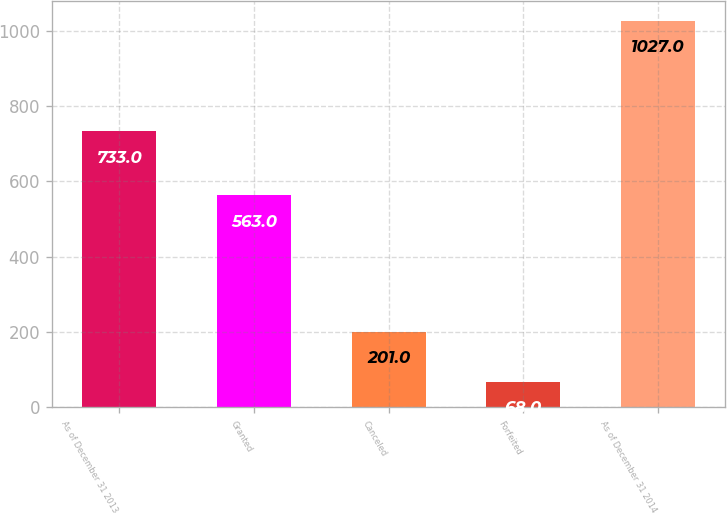Convert chart. <chart><loc_0><loc_0><loc_500><loc_500><bar_chart><fcel>As of December 31 2013<fcel>Granted<fcel>Canceled<fcel>Forfeited<fcel>As of December 31 2014<nl><fcel>733<fcel>563<fcel>201<fcel>68<fcel>1027<nl></chart> 